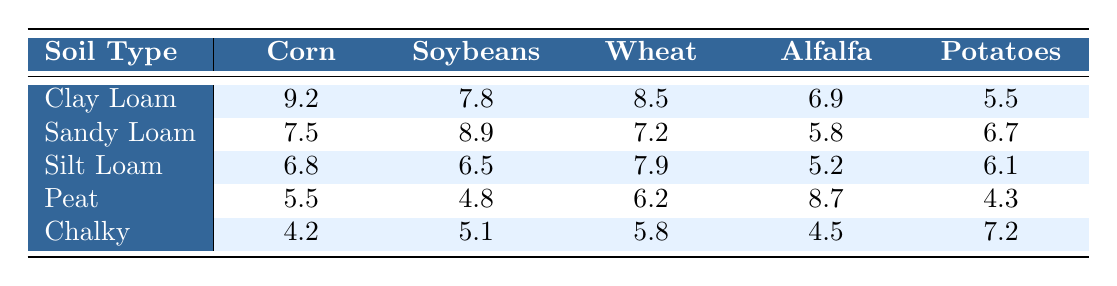What is the highest yield for Corn across all soil types? The highest yield value for Corn in the table is 9.2, which corresponds to the Clay Loam soil type.
Answer: 9.2 Which crop has the lowest yield in Peat soil? Looking at the Peat soil row, the lowest yield is for Soybeans at 4.8.
Answer: 4.8 What is the average yield for Soybeans? Summing the yields for Soybeans: 7.8 (Clay Loam) + 8.9 (Sandy Loam) + 6.5 (Silt Loam) + 4.8 (Peat) + 5.1 (Chalky) equals 33.1. Dividing by the number of soil types (5), the average yield for Soybeans is 33.1 / 5 = 6.62.
Answer: 6.62 Is the yield for Alfalfa higher in Sandy Loam than in Silt Loam? The yield for Alfalfa in Sandy Loam is 5.8, and in Silt Loam, it is 5.2. Since 5.8 is greater than 5.2, the statement is true.
Answer: Yes What is the difference in yield between the highest and lowest producing crops for the Chalky soil type? The highest yield for crops in the Chalky soil is for Potatoes at 7.2, and the lowest is for Corn at 4.2. The difference is 7.2 - 4.2 = 3.0.
Answer: 3.0 Which soil type provides the best yield for Wheat? Looking at the Wheat yields under each soil type, the highest yield is 8.5 in Clay Loam.
Answer: Clay Loam What is the lowest average yield among the five crops across all soil types? The average yields for each crop are: Corn = (9.2 + 7.5 + 6.8 + 5.5 + 4.2) / 5 = 6.84; Soybeans = (7.8 + 8.9 + 6.5 + 4.8 + 5.1) / 5 = 6.64; Wheat = (8.5 + 7.2 + 7.9 + 6.2 + 5.8) / 5 = 7.13; Alfalfa = (6.9 + 5.8 + 5.2 + 8.7 + 4.5) / 5 = 6.42; Potatoes = (5.5 + 6.7 + 6.1 + 4.3 + 7.2) / 5 = 5.78. The lowest average yield is for Potatoes at 5.78.
Answer: 5.78 Which crop had the second-highest yield in Silt Loam? In the Silt Loam row, the yields are: Corn = 6.8, Soybeans = 6.5, Wheat = 7.9, Alfalfa = 5.2, and Potatoes = 6.1. The second-highest yield is for Corn at 6.8.
Answer: Corn If we rank the soil types by their highest crop yields, which soil type ranks third? The highest yields per soil type are: Clay Loam (Corn = 9.2), Sandy Loam (Soybeans = 8.9), Silt Loam (Wheat = 7.9), Peat (Alfalfa = 8.7), and Chalky (Potatoes = 7.2). Ranking these gives: 1st Clay Loam, 2nd Sandy Loam, 3rd Peat.
Answer: Peat 